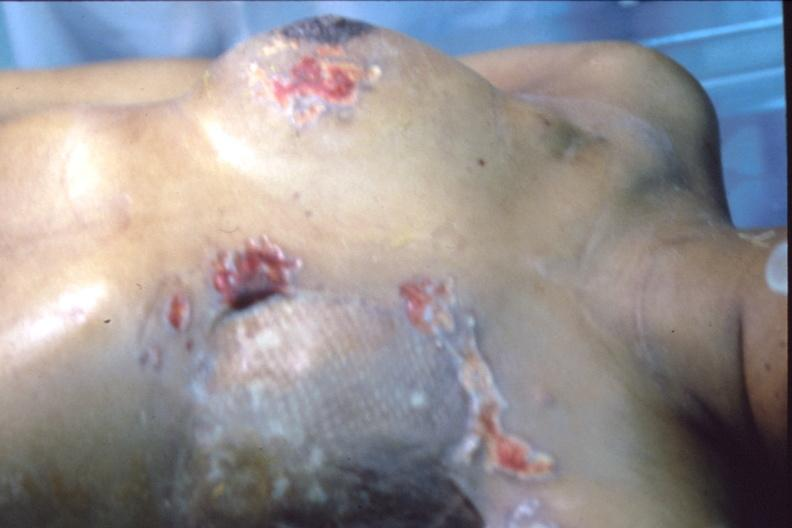how does this image show mastectomy scars?
Answer the question using a single word or phrase. With skin metastases 